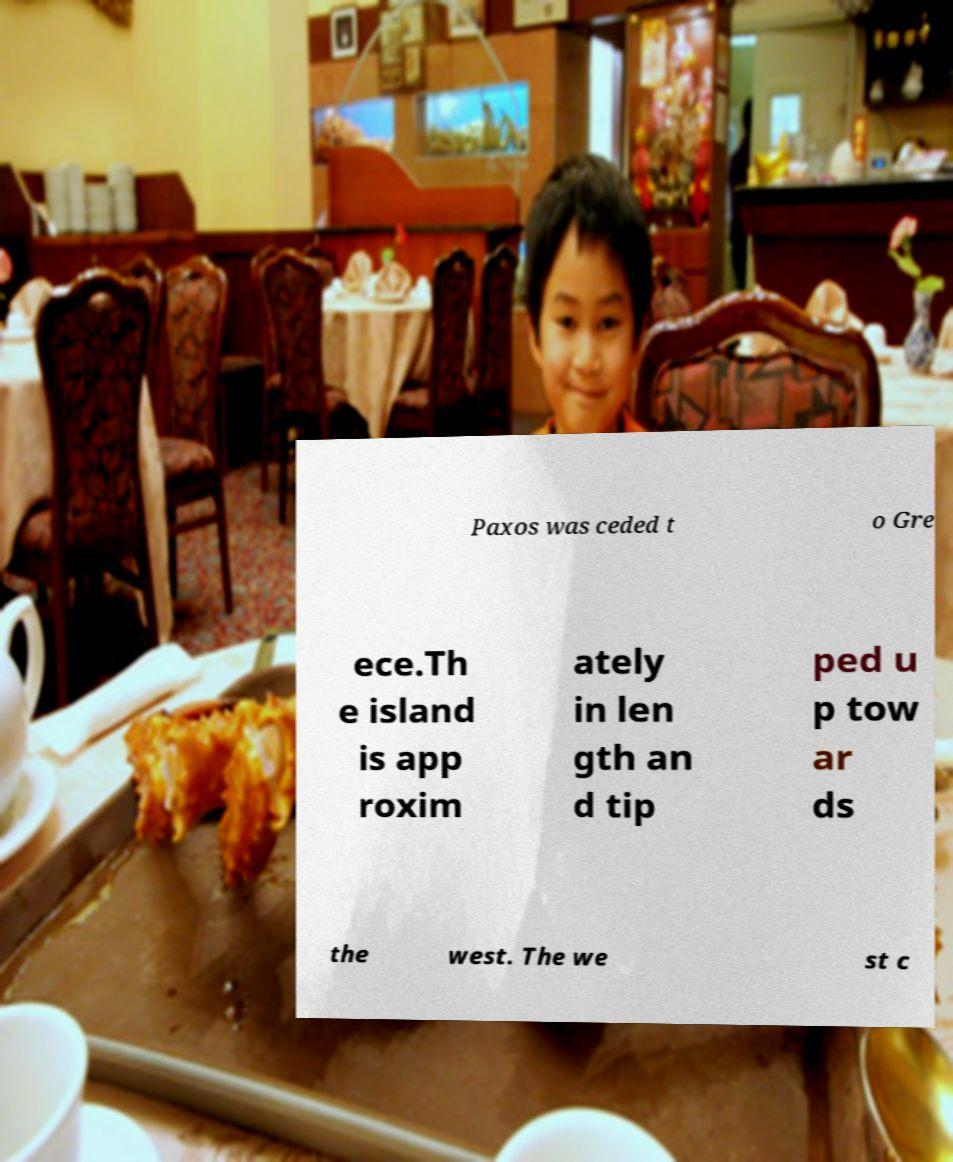Could you extract and type out the text from this image? Paxos was ceded t o Gre ece.Th e island is app roxim ately in len gth an d tip ped u p tow ar ds the west. The we st c 